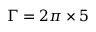Convert formula to latex. <formula><loc_0><loc_0><loc_500><loc_500>\Gamma = 2 \pi \times 5</formula> 